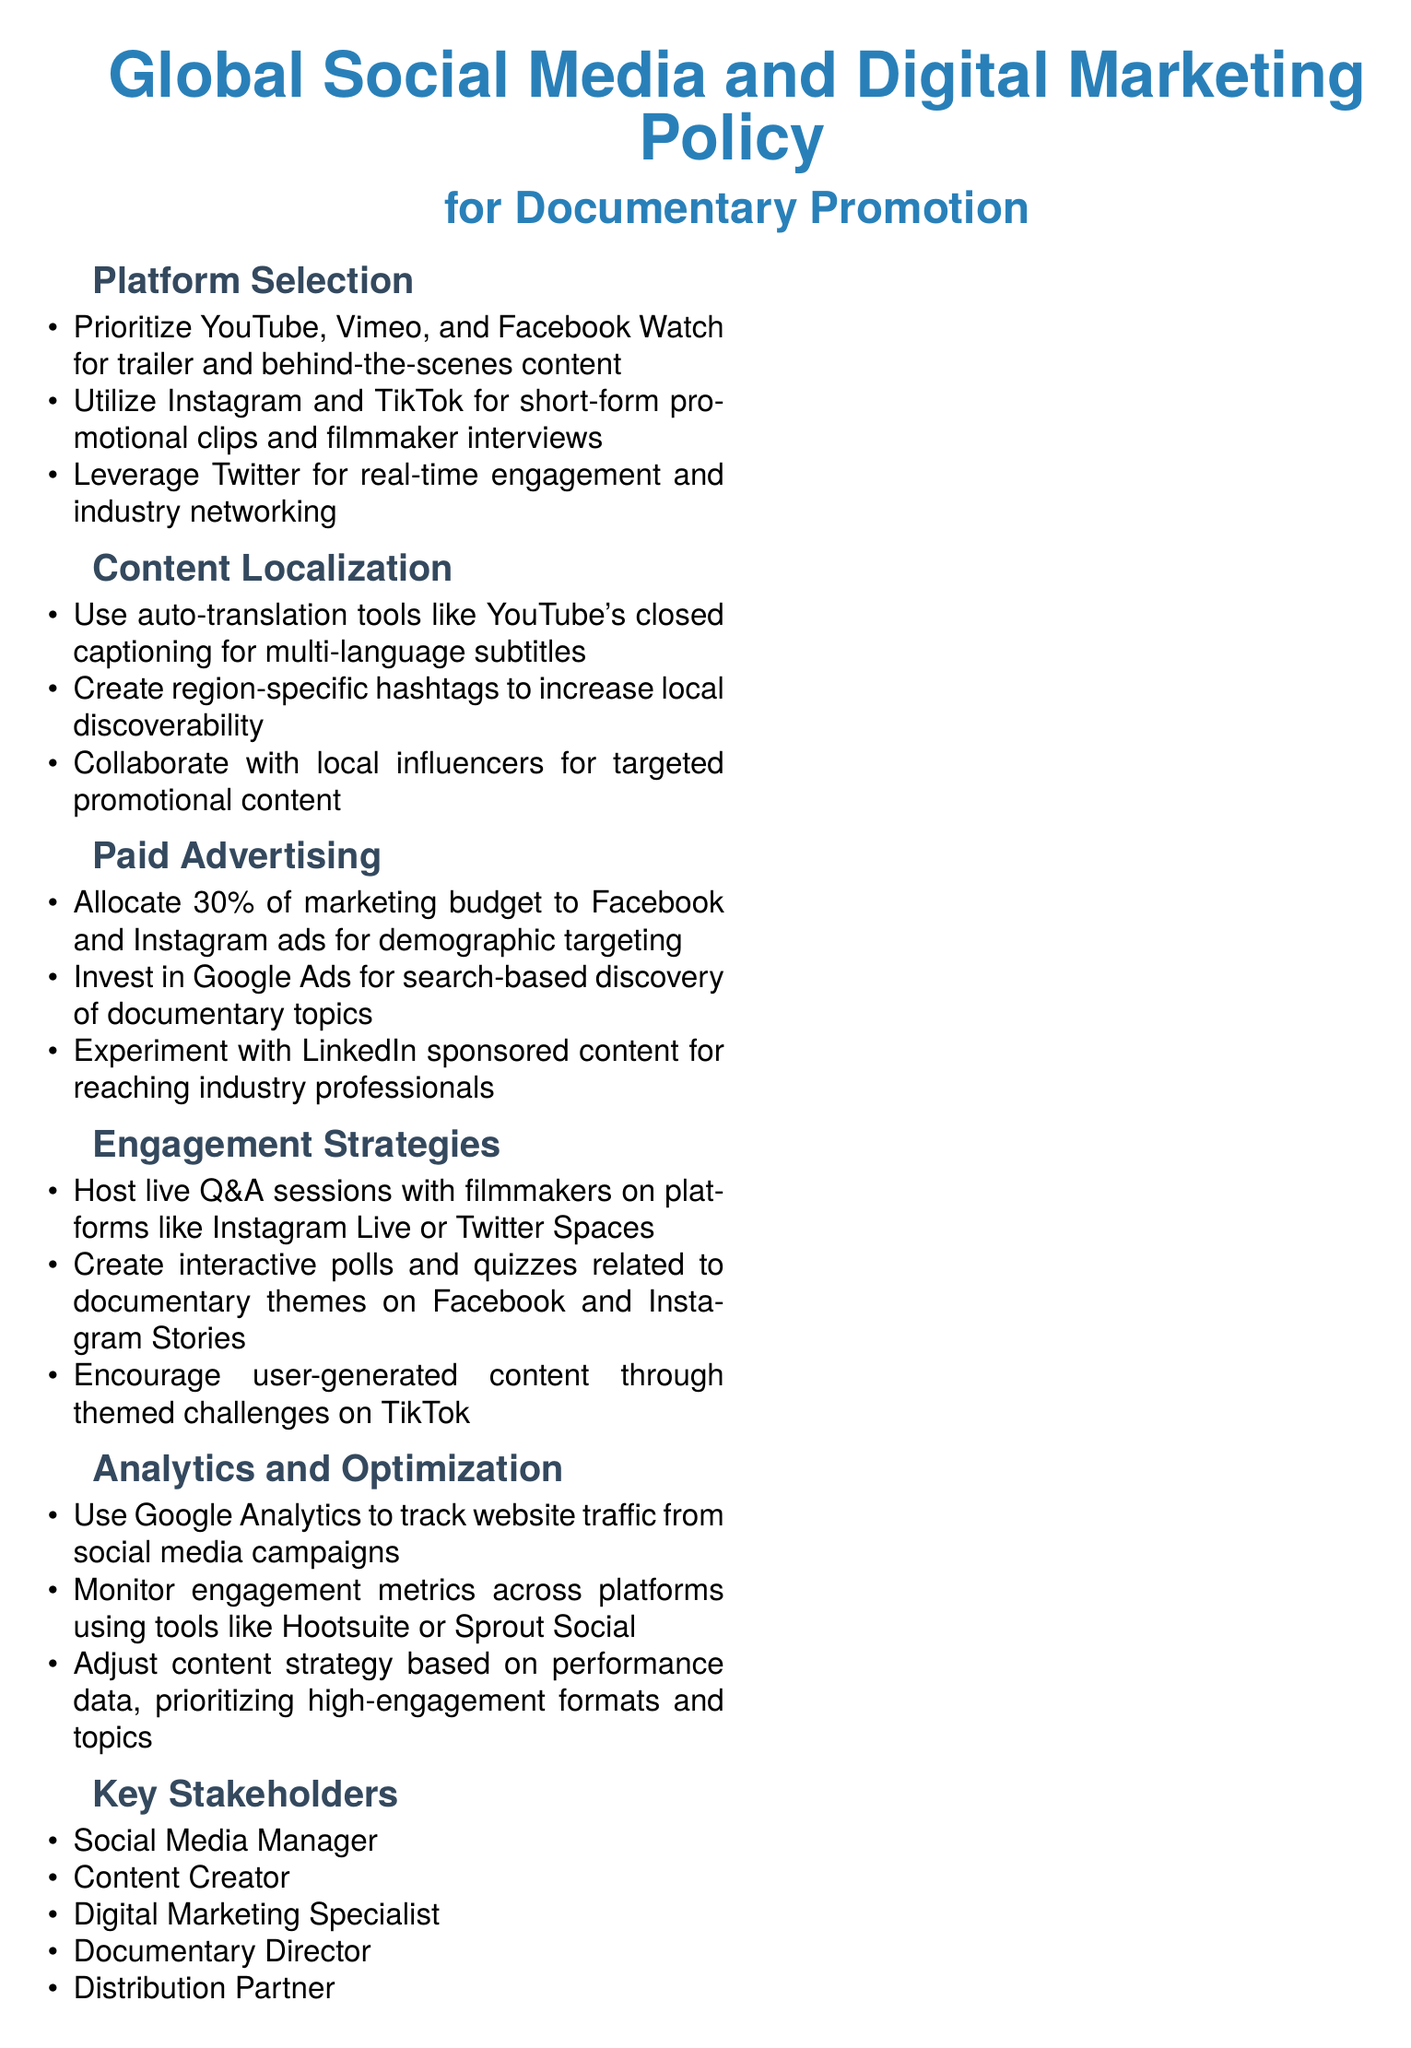What percentage of the marketing budget should be allocated to Facebook and Instagram ads? The document specifies that 30% of the marketing budget should be allocated to Facebook and Instagram ads.
Answer: 30% Which platforms are prioritized for full-length documentary promotion? The document mentions YouTube, Vimeo, and Facebook Watch as the prioritized platforms for trailers and behind-the-scenes content.
Answer: YouTube, Vimeo, Facebook Watch What tool is suggested for tracking website traffic from social media campaigns? The document states that Google Analytics should be used for tracking website traffic.
Answer: Google Analytics What type of content should be created for engagement on Instagram Stories? The document recommends creating interactive polls and quizzes related to documentary themes on Instagram Stories.
Answer: Polls and quizzes Who are considered key stakeholders listed in the policy? The document lists the Social Media Manager, Content Creator, Digital Marketing Specialist, Documentary Director, and Distribution Partner as key stakeholders.
Answer: Social Media Manager, Content Creator, Digital Marketing Specialist, Documentary Director, Distribution Partner What is the frequency of the review cycle mentioned in the document? The document notes that the review cycle is quarterly.
Answer: Quarterly 